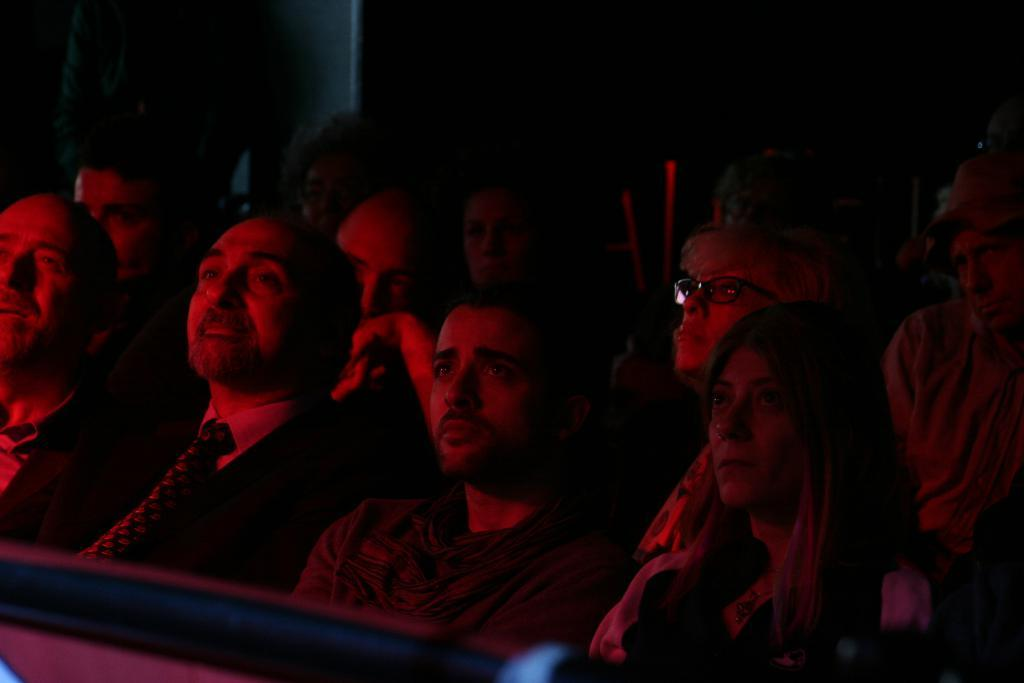What are the people in the image doing? The people in the image are sitting on chairs. What can be observed about the lighting in the image? The background of the image is dark. How many sinks are visible in the image? There are no sinks present in the image. What type of knowledge is being shared among the people in the image? There is no indication of any knowledge being shared in the image; the people are simply sitting on chairs. 